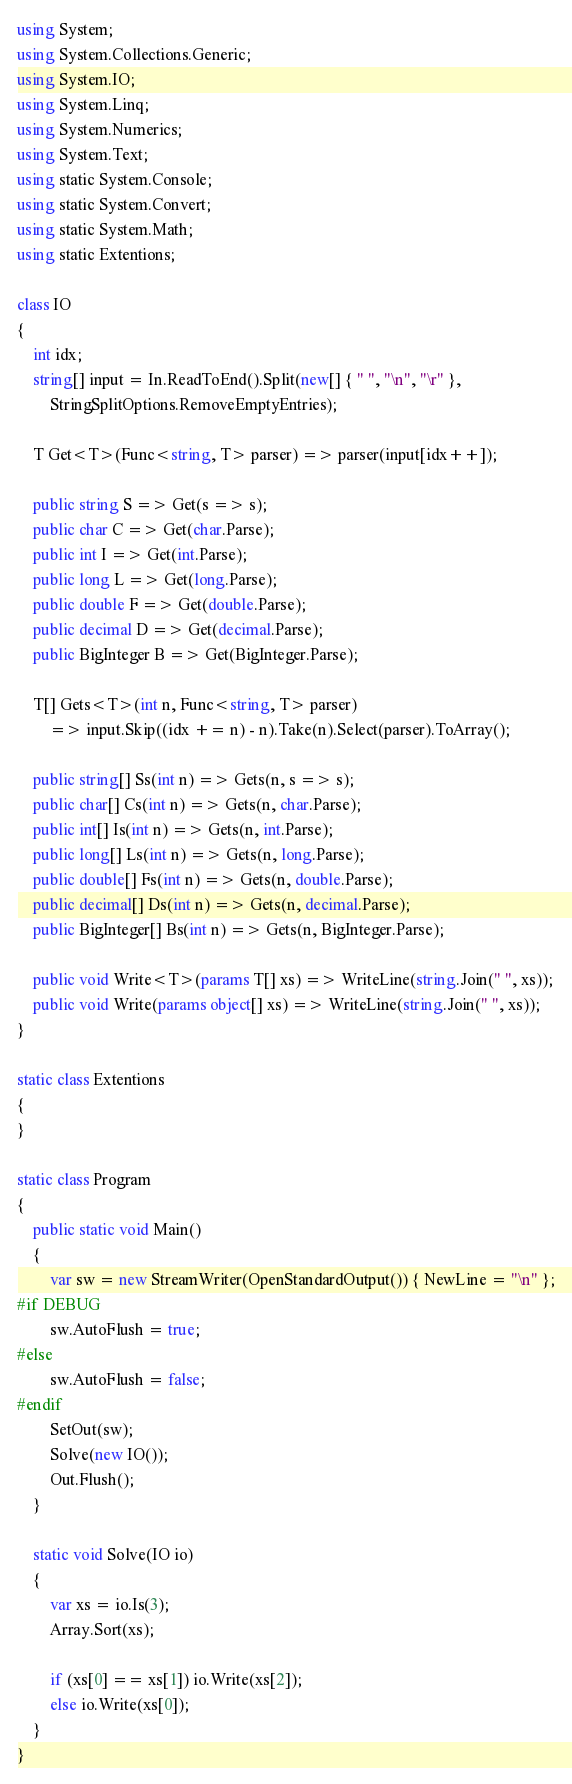Convert code to text. <code><loc_0><loc_0><loc_500><loc_500><_C#_>using System;
using System.Collections.Generic;
using System.IO;
using System.Linq;
using System.Numerics;
using System.Text;
using static System.Console;
using static System.Convert;
using static System.Math;
using static Extentions;

class IO
{
    int idx;
    string[] input = In.ReadToEnd().Split(new[] { " ", "\n", "\r" },
        StringSplitOptions.RemoveEmptyEntries);

    T Get<T>(Func<string, T> parser) => parser(input[idx++]);

    public string S => Get(s => s);
    public char C => Get(char.Parse);
    public int I => Get(int.Parse);
    public long L => Get(long.Parse);
    public double F => Get(double.Parse);
    public decimal D => Get(decimal.Parse);
    public BigInteger B => Get(BigInteger.Parse);

    T[] Gets<T>(int n, Func<string, T> parser)
        => input.Skip((idx += n) - n).Take(n).Select(parser).ToArray();

    public string[] Ss(int n) => Gets(n, s => s);
    public char[] Cs(int n) => Gets(n, char.Parse);
    public int[] Is(int n) => Gets(n, int.Parse);
    public long[] Ls(int n) => Gets(n, long.Parse);
    public double[] Fs(int n) => Gets(n, double.Parse);
    public decimal[] Ds(int n) => Gets(n, decimal.Parse);
    public BigInteger[] Bs(int n) => Gets(n, BigInteger.Parse);

    public void Write<T>(params T[] xs) => WriteLine(string.Join(" ", xs));
    public void Write(params object[] xs) => WriteLine(string.Join(" ", xs));
}

static class Extentions
{
}

static class Program
{
    public static void Main()
    {
        var sw = new StreamWriter(OpenStandardOutput()) { NewLine = "\n" };
#if DEBUG
        sw.AutoFlush = true;
#else
        sw.AutoFlush = false;
#endif
        SetOut(sw);
        Solve(new IO());
        Out.Flush();
    }

    static void Solve(IO io)
    {
        var xs = io.Is(3);
        Array.Sort(xs);

        if (xs[0] == xs[1]) io.Write(xs[2]);
        else io.Write(xs[0]);
    }
}</code> 